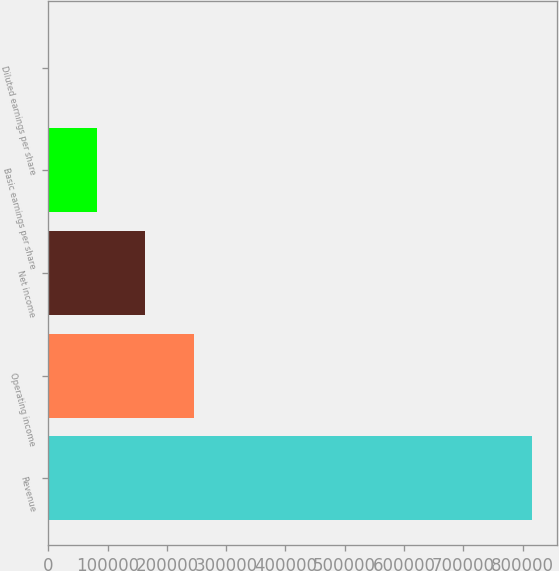Convert chart to OTSL. <chart><loc_0><loc_0><loc_500><loc_500><bar_chart><fcel>Revenue<fcel>Operating income<fcel>Net income<fcel>Basic earnings per share<fcel>Diluted earnings per share<nl><fcel>816786<fcel>245038<fcel>163359<fcel>81681.1<fcel>2.82<nl></chart> 